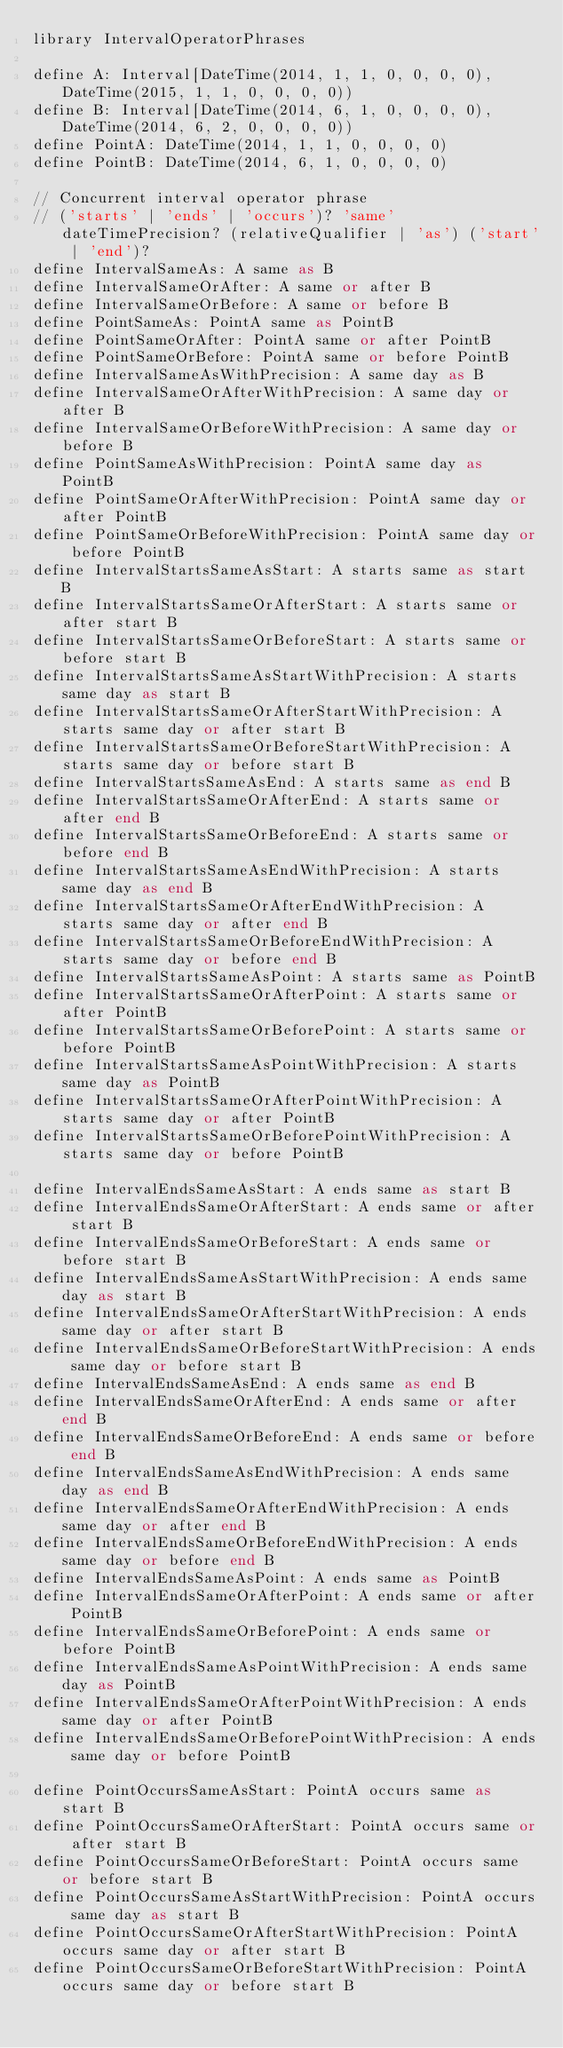Convert code to text. <code><loc_0><loc_0><loc_500><loc_500><_SQL_>library IntervalOperatorPhrases

define A: Interval[DateTime(2014, 1, 1, 0, 0, 0, 0), DateTime(2015, 1, 1, 0, 0, 0, 0))
define B: Interval[DateTime(2014, 6, 1, 0, 0, 0, 0), DateTime(2014, 6, 2, 0, 0, 0, 0))
define PointA: DateTime(2014, 1, 1, 0, 0, 0, 0)
define PointB: DateTime(2014, 6, 1, 0, 0, 0, 0)

// Concurrent interval operator phrase
// ('starts' | 'ends' | 'occurs')? 'same' dateTimePrecision? (relativeQualifier | 'as') ('start' | 'end')?
define IntervalSameAs: A same as B
define IntervalSameOrAfter: A same or after B
define IntervalSameOrBefore: A same or before B
define PointSameAs: PointA same as PointB
define PointSameOrAfter: PointA same or after PointB
define PointSameOrBefore: PointA same or before PointB
define IntervalSameAsWithPrecision: A same day as B
define IntervalSameOrAfterWithPrecision: A same day or after B
define IntervalSameOrBeforeWithPrecision: A same day or before B
define PointSameAsWithPrecision: PointA same day as PointB
define PointSameOrAfterWithPrecision: PointA same day or after PointB
define PointSameOrBeforeWithPrecision: PointA same day or before PointB
define IntervalStartsSameAsStart: A starts same as start B
define IntervalStartsSameOrAfterStart: A starts same or after start B
define IntervalStartsSameOrBeforeStart: A starts same or before start B
define IntervalStartsSameAsStartWithPrecision: A starts same day as start B
define IntervalStartsSameOrAfterStartWithPrecision: A starts same day or after start B
define IntervalStartsSameOrBeforeStartWithPrecision: A starts same day or before start B
define IntervalStartsSameAsEnd: A starts same as end B
define IntervalStartsSameOrAfterEnd: A starts same or after end B
define IntervalStartsSameOrBeforeEnd: A starts same or before end B
define IntervalStartsSameAsEndWithPrecision: A starts same day as end B
define IntervalStartsSameOrAfterEndWithPrecision: A starts same day or after end B
define IntervalStartsSameOrBeforeEndWithPrecision: A starts same day or before end B
define IntervalStartsSameAsPoint: A starts same as PointB
define IntervalStartsSameOrAfterPoint: A starts same or after PointB
define IntervalStartsSameOrBeforePoint: A starts same or before PointB
define IntervalStartsSameAsPointWithPrecision: A starts same day as PointB
define IntervalStartsSameOrAfterPointWithPrecision: A starts same day or after PointB
define IntervalStartsSameOrBeforePointWithPrecision: A starts same day or before PointB

define IntervalEndsSameAsStart: A ends same as start B
define IntervalEndsSameOrAfterStart: A ends same or after start B
define IntervalEndsSameOrBeforeStart: A ends same or before start B
define IntervalEndsSameAsStartWithPrecision: A ends same day as start B
define IntervalEndsSameOrAfterStartWithPrecision: A ends same day or after start B
define IntervalEndsSameOrBeforeStartWithPrecision: A ends same day or before start B
define IntervalEndsSameAsEnd: A ends same as end B
define IntervalEndsSameOrAfterEnd: A ends same or after end B
define IntervalEndsSameOrBeforeEnd: A ends same or before end B
define IntervalEndsSameAsEndWithPrecision: A ends same day as end B
define IntervalEndsSameOrAfterEndWithPrecision: A ends same day or after end B
define IntervalEndsSameOrBeforeEndWithPrecision: A ends same day or before end B
define IntervalEndsSameAsPoint: A ends same as PointB
define IntervalEndsSameOrAfterPoint: A ends same or after PointB
define IntervalEndsSameOrBeforePoint: A ends same or before PointB
define IntervalEndsSameAsPointWithPrecision: A ends same day as PointB
define IntervalEndsSameOrAfterPointWithPrecision: A ends same day or after PointB
define IntervalEndsSameOrBeforePointWithPrecision: A ends same day or before PointB

define PointOccursSameAsStart: PointA occurs same as start B
define PointOccursSameOrAfterStart: PointA occurs same or after start B
define PointOccursSameOrBeforeStart: PointA occurs same or before start B
define PointOccursSameAsStartWithPrecision: PointA occurs same day as start B
define PointOccursSameOrAfterStartWithPrecision: PointA occurs same day or after start B
define PointOccursSameOrBeforeStartWithPrecision: PointA occurs same day or before start B</code> 